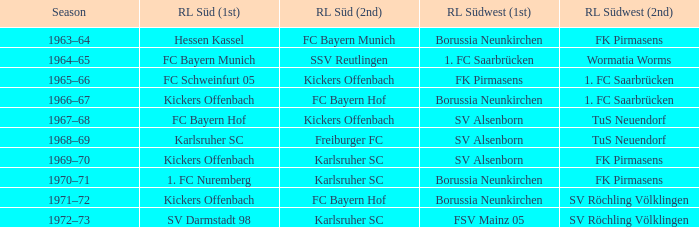Who held the title of rl süd (1st) at the time when fk pirmasens was ranked as rl südwest (1st)? FC Schweinfurt 05. 